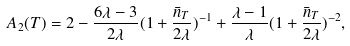Convert formula to latex. <formula><loc_0><loc_0><loc_500><loc_500>A _ { 2 } ( T ) = 2 - \frac { 6 \lambda - 3 } { 2 \lambda } ( 1 + \frac { \bar { n } _ { T } } { 2 \lambda } ) ^ { - 1 } + \frac { \lambda - 1 } { \lambda } ( 1 + \frac { \bar { n } _ { T } } { 2 \lambda } ) ^ { - 2 } ,</formula> 